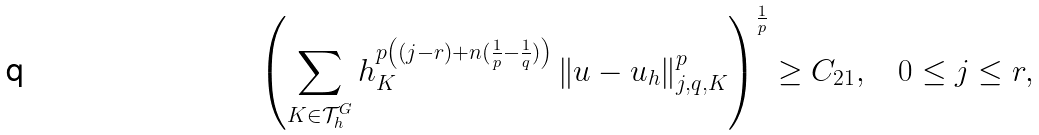<formula> <loc_0><loc_0><loc_500><loc_500>\left ( \sum _ { K \in \mathcal { T } _ { h } ^ { G } } h _ { K } ^ { p \left ( ( j - r ) + n ( \frac { 1 } { p } - \frac { 1 } { q } ) \right ) } \left \| u - u _ { h } \right \| _ { j , q , K } ^ { p } \right ) ^ { \frac { 1 } { p } } \geq C _ { 2 1 } , \quad 0 \leq j \leq r ,</formula> 